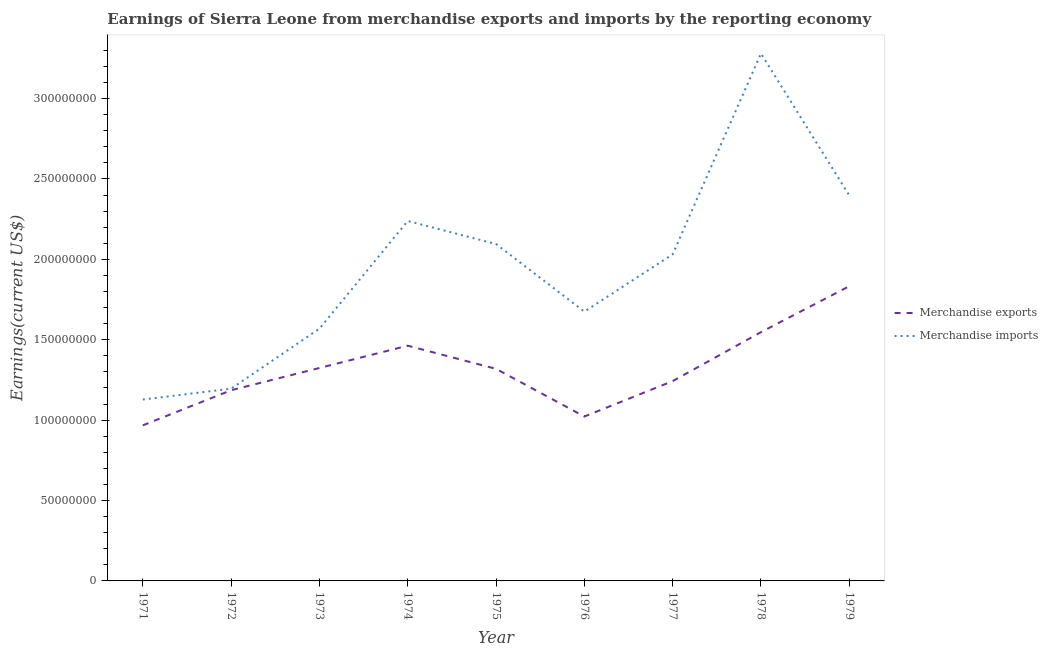How many different coloured lines are there?
Your answer should be very brief. 2. Is the number of lines equal to the number of legend labels?
Your answer should be compact. Yes. What is the earnings from merchandise exports in 1977?
Make the answer very short. 1.24e+08. Across all years, what is the maximum earnings from merchandise exports?
Your answer should be compact. 1.83e+08. Across all years, what is the minimum earnings from merchandise exports?
Ensure brevity in your answer.  9.68e+07. In which year was the earnings from merchandise imports maximum?
Offer a terse response. 1978. What is the total earnings from merchandise exports in the graph?
Keep it short and to the point. 1.19e+09. What is the difference between the earnings from merchandise exports in 1972 and that in 1974?
Your answer should be compact. -2.77e+07. What is the difference between the earnings from merchandise exports in 1974 and the earnings from merchandise imports in 1977?
Ensure brevity in your answer.  -5.68e+07. What is the average earnings from merchandise exports per year?
Your response must be concise. 1.32e+08. In the year 1972, what is the difference between the earnings from merchandise imports and earnings from merchandise exports?
Give a very brief answer. 9.75e+05. In how many years, is the earnings from merchandise exports greater than 170000000 US$?
Ensure brevity in your answer.  1. What is the ratio of the earnings from merchandise imports in 1971 to that in 1973?
Offer a terse response. 0.72. Is the earnings from merchandise imports in 1978 less than that in 1979?
Ensure brevity in your answer.  No. Is the difference between the earnings from merchandise exports in 1971 and 1978 greater than the difference between the earnings from merchandise imports in 1971 and 1978?
Offer a very short reply. Yes. What is the difference between the highest and the second highest earnings from merchandise exports?
Your answer should be very brief. 2.86e+07. What is the difference between the highest and the lowest earnings from merchandise imports?
Make the answer very short. 2.15e+08. Is the sum of the earnings from merchandise imports in 1972 and 1974 greater than the maximum earnings from merchandise exports across all years?
Provide a succinct answer. Yes. Is the earnings from merchandise imports strictly greater than the earnings from merchandise exports over the years?
Make the answer very short. Yes. Is the earnings from merchandise imports strictly less than the earnings from merchandise exports over the years?
Make the answer very short. No. How many lines are there?
Provide a succinct answer. 2. Are the values on the major ticks of Y-axis written in scientific E-notation?
Give a very brief answer. No. Does the graph contain any zero values?
Ensure brevity in your answer.  No. Does the graph contain grids?
Your answer should be very brief. No. How many legend labels are there?
Provide a short and direct response. 2. How are the legend labels stacked?
Offer a terse response. Vertical. What is the title of the graph?
Give a very brief answer. Earnings of Sierra Leone from merchandise exports and imports by the reporting economy. Does "Underweight" appear as one of the legend labels in the graph?
Offer a terse response. No. What is the label or title of the X-axis?
Keep it short and to the point. Year. What is the label or title of the Y-axis?
Ensure brevity in your answer.  Earnings(current US$). What is the Earnings(current US$) in Merchandise exports in 1971?
Keep it short and to the point. 9.68e+07. What is the Earnings(current US$) in Merchandise imports in 1971?
Keep it short and to the point. 1.13e+08. What is the Earnings(current US$) of Merchandise exports in 1972?
Provide a succinct answer. 1.19e+08. What is the Earnings(current US$) in Merchandise imports in 1972?
Ensure brevity in your answer.  1.20e+08. What is the Earnings(current US$) in Merchandise exports in 1973?
Your answer should be very brief. 1.32e+08. What is the Earnings(current US$) in Merchandise imports in 1973?
Ensure brevity in your answer.  1.57e+08. What is the Earnings(current US$) of Merchandise exports in 1974?
Offer a terse response. 1.46e+08. What is the Earnings(current US$) of Merchandise imports in 1974?
Make the answer very short. 2.24e+08. What is the Earnings(current US$) of Merchandise exports in 1975?
Provide a short and direct response. 1.32e+08. What is the Earnings(current US$) of Merchandise imports in 1975?
Make the answer very short. 2.10e+08. What is the Earnings(current US$) in Merchandise exports in 1976?
Keep it short and to the point. 1.02e+08. What is the Earnings(current US$) in Merchandise imports in 1976?
Provide a succinct answer. 1.68e+08. What is the Earnings(current US$) of Merchandise exports in 1977?
Give a very brief answer. 1.24e+08. What is the Earnings(current US$) in Merchandise imports in 1977?
Keep it short and to the point. 2.03e+08. What is the Earnings(current US$) of Merchandise exports in 1978?
Make the answer very short. 1.55e+08. What is the Earnings(current US$) of Merchandise imports in 1978?
Your answer should be very brief. 3.28e+08. What is the Earnings(current US$) of Merchandise exports in 1979?
Provide a succinct answer. 1.83e+08. What is the Earnings(current US$) in Merchandise imports in 1979?
Offer a terse response. 2.40e+08. Across all years, what is the maximum Earnings(current US$) of Merchandise exports?
Keep it short and to the point. 1.83e+08. Across all years, what is the maximum Earnings(current US$) in Merchandise imports?
Give a very brief answer. 3.28e+08. Across all years, what is the minimum Earnings(current US$) of Merchandise exports?
Your answer should be compact. 9.68e+07. Across all years, what is the minimum Earnings(current US$) in Merchandise imports?
Offer a terse response. 1.13e+08. What is the total Earnings(current US$) of Merchandise exports in the graph?
Your answer should be compact. 1.19e+09. What is the total Earnings(current US$) of Merchandise imports in the graph?
Your response must be concise. 1.76e+09. What is the difference between the Earnings(current US$) in Merchandise exports in 1971 and that in 1972?
Keep it short and to the point. -2.18e+07. What is the difference between the Earnings(current US$) of Merchandise imports in 1971 and that in 1972?
Offer a very short reply. -6.76e+06. What is the difference between the Earnings(current US$) of Merchandise exports in 1971 and that in 1973?
Offer a very short reply. -3.57e+07. What is the difference between the Earnings(current US$) in Merchandise imports in 1971 and that in 1973?
Make the answer very short. -4.41e+07. What is the difference between the Earnings(current US$) of Merchandise exports in 1971 and that in 1974?
Give a very brief answer. -4.95e+07. What is the difference between the Earnings(current US$) of Merchandise imports in 1971 and that in 1974?
Provide a succinct answer. -1.11e+08. What is the difference between the Earnings(current US$) in Merchandise exports in 1971 and that in 1975?
Give a very brief answer. -3.51e+07. What is the difference between the Earnings(current US$) in Merchandise imports in 1971 and that in 1975?
Provide a short and direct response. -9.67e+07. What is the difference between the Earnings(current US$) of Merchandise exports in 1971 and that in 1976?
Your answer should be very brief. -5.49e+06. What is the difference between the Earnings(current US$) of Merchandise imports in 1971 and that in 1976?
Offer a very short reply. -5.47e+07. What is the difference between the Earnings(current US$) of Merchandise exports in 1971 and that in 1977?
Your answer should be compact. -2.75e+07. What is the difference between the Earnings(current US$) of Merchandise imports in 1971 and that in 1977?
Give a very brief answer. -9.03e+07. What is the difference between the Earnings(current US$) in Merchandise exports in 1971 and that in 1978?
Give a very brief answer. -5.80e+07. What is the difference between the Earnings(current US$) of Merchandise imports in 1971 and that in 1978?
Your answer should be compact. -2.15e+08. What is the difference between the Earnings(current US$) of Merchandise exports in 1971 and that in 1979?
Ensure brevity in your answer.  -8.65e+07. What is the difference between the Earnings(current US$) of Merchandise imports in 1971 and that in 1979?
Provide a succinct answer. -1.27e+08. What is the difference between the Earnings(current US$) in Merchandise exports in 1972 and that in 1973?
Offer a very short reply. -1.38e+07. What is the difference between the Earnings(current US$) of Merchandise imports in 1972 and that in 1973?
Ensure brevity in your answer.  -3.73e+07. What is the difference between the Earnings(current US$) in Merchandise exports in 1972 and that in 1974?
Offer a terse response. -2.77e+07. What is the difference between the Earnings(current US$) in Merchandise imports in 1972 and that in 1974?
Provide a succinct answer. -1.04e+08. What is the difference between the Earnings(current US$) of Merchandise exports in 1972 and that in 1975?
Give a very brief answer. -1.33e+07. What is the difference between the Earnings(current US$) in Merchandise imports in 1972 and that in 1975?
Provide a short and direct response. -9.00e+07. What is the difference between the Earnings(current US$) in Merchandise exports in 1972 and that in 1976?
Your response must be concise. 1.63e+07. What is the difference between the Earnings(current US$) in Merchandise imports in 1972 and that in 1976?
Give a very brief answer. -4.79e+07. What is the difference between the Earnings(current US$) of Merchandise exports in 1972 and that in 1977?
Your response must be concise. -5.67e+06. What is the difference between the Earnings(current US$) in Merchandise imports in 1972 and that in 1977?
Your answer should be very brief. -8.36e+07. What is the difference between the Earnings(current US$) in Merchandise exports in 1972 and that in 1978?
Offer a terse response. -3.61e+07. What is the difference between the Earnings(current US$) of Merchandise imports in 1972 and that in 1978?
Offer a terse response. -2.08e+08. What is the difference between the Earnings(current US$) of Merchandise exports in 1972 and that in 1979?
Ensure brevity in your answer.  -6.47e+07. What is the difference between the Earnings(current US$) in Merchandise imports in 1972 and that in 1979?
Keep it short and to the point. -1.20e+08. What is the difference between the Earnings(current US$) in Merchandise exports in 1973 and that in 1974?
Ensure brevity in your answer.  -1.39e+07. What is the difference between the Earnings(current US$) in Merchandise imports in 1973 and that in 1974?
Offer a terse response. -6.70e+07. What is the difference between the Earnings(current US$) in Merchandise exports in 1973 and that in 1975?
Give a very brief answer. 5.35e+05. What is the difference between the Earnings(current US$) in Merchandise imports in 1973 and that in 1975?
Your response must be concise. -5.26e+07. What is the difference between the Earnings(current US$) of Merchandise exports in 1973 and that in 1976?
Make the answer very short. 3.02e+07. What is the difference between the Earnings(current US$) in Merchandise imports in 1973 and that in 1976?
Provide a short and direct response. -1.06e+07. What is the difference between the Earnings(current US$) in Merchandise exports in 1973 and that in 1977?
Make the answer very short. 8.18e+06. What is the difference between the Earnings(current US$) of Merchandise imports in 1973 and that in 1977?
Give a very brief answer. -4.62e+07. What is the difference between the Earnings(current US$) in Merchandise exports in 1973 and that in 1978?
Keep it short and to the point. -2.23e+07. What is the difference between the Earnings(current US$) of Merchandise imports in 1973 and that in 1978?
Ensure brevity in your answer.  -1.71e+08. What is the difference between the Earnings(current US$) of Merchandise exports in 1973 and that in 1979?
Give a very brief answer. -5.09e+07. What is the difference between the Earnings(current US$) of Merchandise imports in 1973 and that in 1979?
Provide a short and direct response. -8.29e+07. What is the difference between the Earnings(current US$) in Merchandise exports in 1974 and that in 1975?
Give a very brief answer. 1.44e+07. What is the difference between the Earnings(current US$) of Merchandise imports in 1974 and that in 1975?
Your answer should be very brief. 1.43e+07. What is the difference between the Earnings(current US$) in Merchandise exports in 1974 and that in 1976?
Ensure brevity in your answer.  4.40e+07. What is the difference between the Earnings(current US$) of Merchandise imports in 1974 and that in 1976?
Your answer should be very brief. 5.64e+07. What is the difference between the Earnings(current US$) of Merchandise exports in 1974 and that in 1977?
Provide a succinct answer. 2.20e+07. What is the difference between the Earnings(current US$) in Merchandise imports in 1974 and that in 1977?
Make the answer very short. 2.07e+07. What is the difference between the Earnings(current US$) of Merchandise exports in 1974 and that in 1978?
Offer a very short reply. -8.42e+06. What is the difference between the Earnings(current US$) in Merchandise imports in 1974 and that in 1978?
Offer a very short reply. -1.04e+08. What is the difference between the Earnings(current US$) of Merchandise exports in 1974 and that in 1979?
Offer a terse response. -3.70e+07. What is the difference between the Earnings(current US$) in Merchandise imports in 1974 and that in 1979?
Make the answer very short. -1.59e+07. What is the difference between the Earnings(current US$) of Merchandise exports in 1975 and that in 1976?
Offer a terse response. 2.97e+07. What is the difference between the Earnings(current US$) in Merchandise imports in 1975 and that in 1976?
Give a very brief answer. 4.20e+07. What is the difference between the Earnings(current US$) of Merchandise exports in 1975 and that in 1977?
Ensure brevity in your answer.  7.64e+06. What is the difference between the Earnings(current US$) in Merchandise imports in 1975 and that in 1977?
Keep it short and to the point. 6.39e+06. What is the difference between the Earnings(current US$) in Merchandise exports in 1975 and that in 1978?
Your answer should be very brief. -2.28e+07. What is the difference between the Earnings(current US$) in Merchandise imports in 1975 and that in 1978?
Your answer should be compact. -1.19e+08. What is the difference between the Earnings(current US$) of Merchandise exports in 1975 and that in 1979?
Offer a terse response. -5.14e+07. What is the difference between the Earnings(current US$) in Merchandise imports in 1975 and that in 1979?
Your response must be concise. -3.02e+07. What is the difference between the Earnings(current US$) in Merchandise exports in 1976 and that in 1977?
Your answer should be compact. -2.20e+07. What is the difference between the Earnings(current US$) of Merchandise imports in 1976 and that in 1977?
Provide a succinct answer. -3.56e+07. What is the difference between the Earnings(current US$) of Merchandise exports in 1976 and that in 1978?
Offer a very short reply. -5.25e+07. What is the difference between the Earnings(current US$) of Merchandise imports in 1976 and that in 1978?
Ensure brevity in your answer.  -1.61e+08. What is the difference between the Earnings(current US$) in Merchandise exports in 1976 and that in 1979?
Make the answer very short. -8.11e+07. What is the difference between the Earnings(current US$) in Merchandise imports in 1976 and that in 1979?
Ensure brevity in your answer.  -7.22e+07. What is the difference between the Earnings(current US$) in Merchandise exports in 1977 and that in 1978?
Your answer should be very brief. -3.05e+07. What is the difference between the Earnings(current US$) of Merchandise imports in 1977 and that in 1978?
Offer a very short reply. -1.25e+08. What is the difference between the Earnings(current US$) of Merchandise exports in 1977 and that in 1979?
Provide a succinct answer. -5.90e+07. What is the difference between the Earnings(current US$) of Merchandise imports in 1977 and that in 1979?
Provide a succinct answer. -3.66e+07. What is the difference between the Earnings(current US$) of Merchandise exports in 1978 and that in 1979?
Your response must be concise. -2.86e+07. What is the difference between the Earnings(current US$) of Merchandise imports in 1978 and that in 1979?
Offer a very short reply. 8.83e+07. What is the difference between the Earnings(current US$) in Merchandise exports in 1971 and the Earnings(current US$) in Merchandise imports in 1972?
Give a very brief answer. -2.28e+07. What is the difference between the Earnings(current US$) of Merchandise exports in 1971 and the Earnings(current US$) of Merchandise imports in 1973?
Your answer should be compact. -6.01e+07. What is the difference between the Earnings(current US$) of Merchandise exports in 1971 and the Earnings(current US$) of Merchandise imports in 1974?
Offer a very short reply. -1.27e+08. What is the difference between the Earnings(current US$) in Merchandise exports in 1971 and the Earnings(current US$) in Merchandise imports in 1975?
Keep it short and to the point. -1.13e+08. What is the difference between the Earnings(current US$) in Merchandise exports in 1971 and the Earnings(current US$) in Merchandise imports in 1976?
Give a very brief answer. -7.07e+07. What is the difference between the Earnings(current US$) of Merchandise exports in 1971 and the Earnings(current US$) of Merchandise imports in 1977?
Give a very brief answer. -1.06e+08. What is the difference between the Earnings(current US$) of Merchandise exports in 1971 and the Earnings(current US$) of Merchandise imports in 1978?
Keep it short and to the point. -2.31e+08. What is the difference between the Earnings(current US$) in Merchandise exports in 1971 and the Earnings(current US$) in Merchandise imports in 1979?
Offer a terse response. -1.43e+08. What is the difference between the Earnings(current US$) of Merchandise exports in 1972 and the Earnings(current US$) of Merchandise imports in 1973?
Provide a succinct answer. -3.83e+07. What is the difference between the Earnings(current US$) in Merchandise exports in 1972 and the Earnings(current US$) in Merchandise imports in 1974?
Ensure brevity in your answer.  -1.05e+08. What is the difference between the Earnings(current US$) of Merchandise exports in 1972 and the Earnings(current US$) of Merchandise imports in 1975?
Ensure brevity in your answer.  -9.09e+07. What is the difference between the Earnings(current US$) of Merchandise exports in 1972 and the Earnings(current US$) of Merchandise imports in 1976?
Your response must be concise. -4.89e+07. What is the difference between the Earnings(current US$) of Merchandise exports in 1972 and the Earnings(current US$) of Merchandise imports in 1977?
Provide a short and direct response. -8.45e+07. What is the difference between the Earnings(current US$) in Merchandise exports in 1972 and the Earnings(current US$) in Merchandise imports in 1978?
Keep it short and to the point. -2.09e+08. What is the difference between the Earnings(current US$) in Merchandise exports in 1972 and the Earnings(current US$) in Merchandise imports in 1979?
Your response must be concise. -1.21e+08. What is the difference between the Earnings(current US$) of Merchandise exports in 1973 and the Earnings(current US$) of Merchandise imports in 1974?
Keep it short and to the point. -9.14e+07. What is the difference between the Earnings(current US$) of Merchandise exports in 1973 and the Earnings(current US$) of Merchandise imports in 1975?
Offer a very short reply. -7.71e+07. What is the difference between the Earnings(current US$) in Merchandise exports in 1973 and the Earnings(current US$) in Merchandise imports in 1976?
Provide a succinct answer. -3.51e+07. What is the difference between the Earnings(current US$) in Merchandise exports in 1973 and the Earnings(current US$) in Merchandise imports in 1977?
Give a very brief answer. -7.07e+07. What is the difference between the Earnings(current US$) in Merchandise exports in 1973 and the Earnings(current US$) in Merchandise imports in 1978?
Make the answer very short. -1.96e+08. What is the difference between the Earnings(current US$) of Merchandise exports in 1973 and the Earnings(current US$) of Merchandise imports in 1979?
Keep it short and to the point. -1.07e+08. What is the difference between the Earnings(current US$) of Merchandise exports in 1974 and the Earnings(current US$) of Merchandise imports in 1975?
Make the answer very short. -6.32e+07. What is the difference between the Earnings(current US$) of Merchandise exports in 1974 and the Earnings(current US$) of Merchandise imports in 1976?
Give a very brief answer. -2.12e+07. What is the difference between the Earnings(current US$) of Merchandise exports in 1974 and the Earnings(current US$) of Merchandise imports in 1977?
Your response must be concise. -5.68e+07. What is the difference between the Earnings(current US$) of Merchandise exports in 1974 and the Earnings(current US$) of Merchandise imports in 1978?
Make the answer very short. -1.82e+08. What is the difference between the Earnings(current US$) of Merchandise exports in 1974 and the Earnings(current US$) of Merchandise imports in 1979?
Keep it short and to the point. -9.35e+07. What is the difference between the Earnings(current US$) in Merchandise exports in 1975 and the Earnings(current US$) in Merchandise imports in 1976?
Your answer should be compact. -3.56e+07. What is the difference between the Earnings(current US$) of Merchandise exports in 1975 and the Earnings(current US$) of Merchandise imports in 1977?
Provide a succinct answer. -7.12e+07. What is the difference between the Earnings(current US$) of Merchandise exports in 1975 and the Earnings(current US$) of Merchandise imports in 1978?
Provide a short and direct response. -1.96e+08. What is the difference between the Earnings(current US$) of Merchandise exports in 1975 and the Earnings(current US$) of Merchandise imports in 1979?
Give a very brief answer. -1.08e+08. What is the difference between the Earnings(current US$) in Merchandise exports in 1976 and the Earnings(current US$) in Merchandise imports in 1977?
Your response must be concise. -1.01e+08. What is the difference between the Earnings(current US$) of Merchandise exports in 1976 and the Earnings(current US$) of Merchandise imports in 1978?
Your answer should be very brief. -2.26e+08. What is the difference between the Earnings(current US$) of Merchandise exports in 1976 and the Earnings(current US$) of Merchandise imports in 1979?
Offer a terse response. -1.38e+08. What is the difference between the Earnings(current US$) of Merchandise exports in 1977 and the Earnings(current US$) of Merchandise imports in 1978?
Provide a short and direct response. -2.04e+08. What is the difference between the Earnings(current US$) in Merchandise exports in 1977 and the Earnings(current US$) in Merchandise imports in 1979?
Your answer should be very brief. -1.15e+08. What is the difference between the Earnings(current US$) in Merchandise exports in 1978 and the Earnings(current US$) in Merchandise imports in 1979?
Ensure brevity in your answer.  -8.50e+07. What is the average Earnings(current US$) in Merchandise exports per year?
Provide a short and direct response. 1.32e+08. What is the average Earnings(current US$) in Merchandise imports per year?
Keep it short and to the point. 1.96e+08. In the year 1971, what is the difference between the Earnings(current US$) of Merchandise exports and Earnings(current US$) of Merchandise imports?
Keep it short and to the point. -1.60e+07. In the year 1972, what is the difference between the Earnings(current US$) in Merchandise exports and Earnings(current US$) in Merchandise imports?
Give a very brief answer. -9.75e+05. In the year 1973, what is the difference between the Earnings(current US$) of Merchandise exports and Earnings(current US$) of Merchandise imports?
Provide a short and direct response. -2.44e+07. In the year 1974, what is the difference between the Earnings(current US$) in Merchandise exports and Earnings(current US$) in Merchandise imports?
Your answer should be very brief. -7.76e+07. In the year 1975, what is the difference between the Earnings(current US$) of Merchandise exports and Earnings(current US$) of Merchandise imports?
Your answer should be compact. -7.76e+07. In the year 1976, what is the difference between the Earnings(current US$) in Merchandise exports and Earnings(current US$) in Merchandise imports?
Give a very brief answer. -6.53e+07. In the year 1977, what is the difference between the Earnings(current US$) of Merchandise exports and Earnings(current US$) of Merchandise imports?
Your answer should be compact. -7.89e+07. In the year 1978, what is the difference between the Earnings(current US$) in Merchandise exports and Earnings(current US$) in Merchandise imports?
Offer a very short reply. -1.73e+08. In the year 1979, what is the difference between the Earnings(current US$) of Merchandise exports and Earnings(current US$) of Merchandise imports?
Give a very brief answer. -5.64e+07. What is the ratio of the Earnings(current US$) in Merchandise exports in 1971 to that in 1972?
Provide a succinct answer. 0.82. What is the ratio of the Earnings(current US$) of Merchandise imports in 1971 to that in 1972?
Your answer should be compact. 0.94. What is the ratio of the Earnings(current US$) of Merchandise exports in 1971 to that in 1973?
Your response must be concise. 0.73. What is the ratio of the Earnings(current US$) in Merchandise imports in 1971 to that in 1973?
Provide a succinct answer. 0.72. What is the ratio of the Earnings(current US$) of Merchandise exports in 1971 to that in 1974?
Your answer should be very brief. 0.66. What is the ratio of the Earnings(current US$) of Merchandise imports in 1971 to that in 1974?
Provide a succinct answer. 0.5. What is the ratio of the Earnings(current US$) in Merchandise exports in 1971 to that in 1975?
Keep it short and to the point. 0.73. What is the ratio of the Earnings(current US$) in Merchandise imports in 1971 to that in 1975?
Give a very brief answer. 0.54. What is the ratio of the Earnings(current US$) of Merchandise exports in 1971 to that in 1976?
Your response must be concise. 0.95. What is the ratio of the Earnings(current US$) in Merchandise imports in 1971 to that in 1976?
Give a very brief answer. 0.67. What is the ratio of the Earnings(current US$) in Merchandise exports in 1971 to that in 1977?
Ensure brevity in your answer.  0.78. What is the ratio of the Earnings(current US$) of Merchandise imports in 1971 to that in 1977?
Ensure brevity in your answer.  0.56. What is the ratio of the Earnings(current US$) in Merchandise exports in 1971 to that in 1978?
Provide a short and direct response. 0.63. What is the ratio of the Earnings(current US$) in Merchandise imports in 1971 to that in 1978?
Your answer should be very brief. 0.34. What is the ratio of the Earnings(current US$) in Merchandise exports in 1971 to that in 1979?
Your response must be concise. 0.53. What is the ratio of the Earnings(current US$) in Merchandise imports in 1971 to that in 1979?
Offer a very short reply. 0.47. What is the ratio of the Earnings(current US$) of Merchandise exports in 1972 to that in 1973?
Ensure brevity in your answer.  0.9. What is the ratio of the Earnings(current US$) of Merchandise imports in 1972 to that in 1973?
Make the answer very short. 0.76. What is the ratio of the Earnings(current US$) in Merchandise exports in 1972 to that in 1974?
Make the answer very short. 0.81. What is the ratio of the Earnings(current US$) of Merchandise imports in 1972 to that in 1974?
Your answer should be very brief. 0.53. What is the ratio of the Earnings(current US$) of Merchandise exports in 1972 to that in 1975?
Your answer should be compact. 0.9. What is the ratio of the Earnings(current US$) of Merchandise imports in 1972 to that in 1975?
Offer a very short reply. 0.57. What is the ratio of the Earnings(current US$) of Merchandise exports in 1972 to that in 1976?
Ensure brevity in your answer.  1.16. What is the ratio of the Earnings(current US$) in Merchandise imports in 1972 to that in 1976?
Offer a terse response. 0.71. What is the ratio of the Earnings(current US$) in Merchandise exports in 1972 to that in 1977?
Make the answer very short. 0.95. What is the ratio of the Earnings(current US$) in Merchandise imports in 1972 to that in 1977?
Provide a short and direct response. 0.59. What is the ratio of the Earnings(current US$) in Merchandise exports in 1972 to that in 1978?
Provide a short and direct response. 0.77. What is the ratio of the Earnings(current US$) in Merchandise imports in 1972 to that in 1978?
Your answer should be very brief. 0.36. What is the ratio of the Earnings(current US$) in Merchandise exports in 1972 to that in 1979?
Make the answer very short. 0.65. What is the ratio of the Earnings(current US$) of Merchandise imports in 1972 to that in 1979?
Give a very brief answer. 0.5. What is the ratio of the Earnings(current US$) of Merchandise exports in 1973 to that in 1974?
Your answer should be very brief. 0.91. What is the ratio of the Earnings(current US$) of Merchandise imports in 1973 to that in 1974?
Provide a short and direct response. 0.7. What is the ratio of the Earnings(current US$) in Merchandise exports in 1973 to that in 1975?
Offer a very short reply. 1. What is the ratio of the Earnings(current US$) of Merchandise imports in 1973 to that in 1975?
Your answer should be compact. 0.75. What is the ratio of the Earnings(current US$) of Merchandise exports in 1973 to that in 1976?
Give a very brief answer. 1.3. What is the ratio of the Earnings(current US$) of Merchandise imports in 1973 to that in 1976?
Your response must be concise. 0.94. What is the ratio of the Earnings(current US$) of Merchandise exports in 1973 to that in 1977?
Provide a succinct answer. 1.07. What is the ratio of the Earnings(current US$) in Merchandise imports in 1973 to that in 1977?
Your answer should be compact. 0.77. What is the ratio of the Earnings(current US$) of Merchandise exports in 1973 to that in 1978?
Your answer should be very brief. 0.86. What is the ratio of the Earnings(current US$) of Merchandise imports in 1973 to that in 1978?
Your response must be concise. 0.48. What is the ratio of the Earnings(current US$) in Merchandise exports in 1973 to that in 1979?
Your response must be concise. 0.72. What is the ratio of the Earnings(current US$) of Merchandise imports in 1973 to that in 1979?
Provide a short and direct response. 0.65. What is the ratio of the Earnings(current US$) of Merchandise exports in 1974 to that in 1975?
Ensure brevity in your answer.  1.11. What is the ratio of the Earnings(current US$) in Merchandise imports in 1974 to that in 1975?
Offer a very short reply. 1.07. What is the ratio of the Earnings(current US$) of Merchandise exports in 1974 to that in 1976?
Make the answer very short. 1.43. What is the ratio of the Earnings(current US$) in Merchandise imports in 1974 to that in 1976?
Your answer should be compact. 1.34. What is the ratio of the Earnings(current US$) of Merchandise exports in 1974 to that in 1977?
Ensure brevity in your answer.  1.18. What is the ratio of the Earnings(current US$) in Merchandise imports in 1974 to that in 1977?
Keep it short and to the point. 1.1. What is the ratio of the Earnings(current US$) of Merchandise exports in 1974 to that in 1978?
Keep it short and to the point. 0.95. What is the ratio of the Earnings(current US$) of Merchandise imports in 1974 to that in 1978?
Ensure brevity in your answer.  0.68. What is the ratio of the Earnings(current US$) in Merchandise exports in 1974 to that in 1979?
Provide a short and direct response. 0.8. What is the ratio of the Earnings(current US$) in Merchandise imports in 1974 to that in 1979?
Your answer should be very brief. 0.93. What is the ratio of the Earnings(current US$) of Merchandise exports in 1975 to that in 1976?
Ensure brevity in your answer.  1.29. What is the ratio of the Earnings(current US$) of Merchandise imports in 1975 to that in 1976?
Provide a short and direct response. 1.25. What is the ratio of the Earnings(current US$) in Merchandise exports in 1975 to that in 1977?
Make the answer very short. 1.06. What is the ratio of the Earnings(current US$) of Merchandise imports in 1975 to that in 1977?
Your answer should be compact. 1.03. What is the ratio of the Earnings(current US$) of Merchandise exports in 1975 to that in 1978?
Your answer should be very brief. 0.85. What is the ratio of the Earnings(current US$) in Merchandise imports in 1975 to that in 1978?
Keep it short and to the point. 0.64. What is the ratio of the Earnings(current US$) in Merchandise exports in 1975 to that in 1979?
Keep it short and to the point. 0.72. What is the ratio of the Earnings(current US$) of Merchandise imports in 1975 to that in 1979?
Provide a succinct answer. 0.87. What is the ratio of the Earnings(current US$) of Merchandise exports in 1976 to that in 1977?
Offer a terse response. 0.82. What is the ratio of the Earnings(current US$) in Merchandise imports in 1976 to that in 1977?
Provide a short and direct response. 0.82. What is the ratio of the Earnings(current US$) of Merchandise exports in 1976 to that in 1978?
Provide a succinct answer. 0.66. What is the ratio of the Earnings(current US$) of Merchandise imports in 1976 to that in 1978?
Offer a very short reply. 0.51. What is the ratio of the Earnings(current US$) in Merchandise exports in 1976 to that in 1979?
Make the answer very short. 0.56. What is the ratio of the Earnings(current US$) of Merchandise imports in 1976 to that in 1979?
Give a very brief answer. 0.7. What is the ratio of the Earnings(current US$) of Merchandise exports in 1977 to that in 1978?
Offer a terse response. 0.8. What is the ratio of the Earnings(current US$) in Merchandise imports in 1977 to that in 1978?
Your answer should be compact. 0.62. What is the ratio of the Earnings(current US$) in Merchandise exports in 1977 to that in 1979?
Offer a terse response. 0.68. What is the ratio of the Earnings(current US$) of Merchandise imports in 1977 to that in 1979?
Your response must be concise. 0.85. What is the ratio of the Earnings(current US$) of Merchandise exports in 1978 to that in 1979?
Provide a short and direct response. 0.84. What is the ratio of the Earnings(current US$) of Merchandise imports in 1978 to that in 1979?
Offer a very short reply. 1.37. What is the difference between the highest and the second highest Earnings(current US$) of Merchandise exports?
Your answer should be compact. 2.86e+07. What is the difference between the highest and the second highest Earnings(current US$) in Merchandise imports?
Your answer should be compact. 8.83e+07. What is the difference between the highest and the lowest Earnings(current US$) of Merchandise exports?
Your answer should be compact. 8.65e+07. What is the difference between the highest and the lowest Earnings(current US$) in Merchandise imports?
Provide a succinct answer. 2.15e+08. 